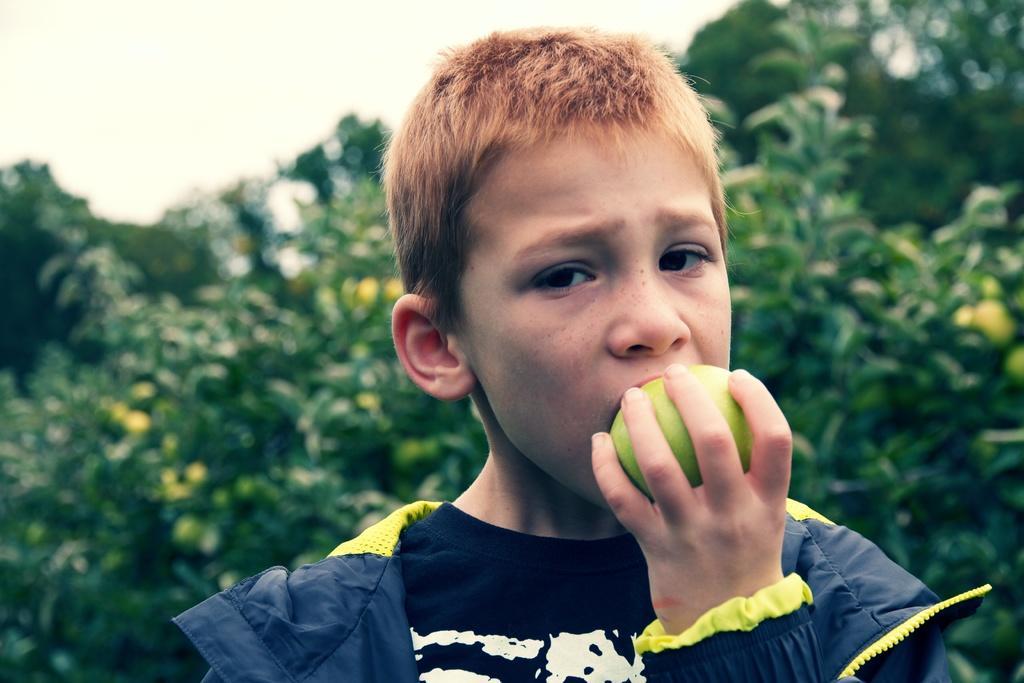Please provide a concise description of this image. In this image I can see the person holding the green color fruit. The person is wearing the navy blue and yellow color dress. In the back there are many trees and the sky. 